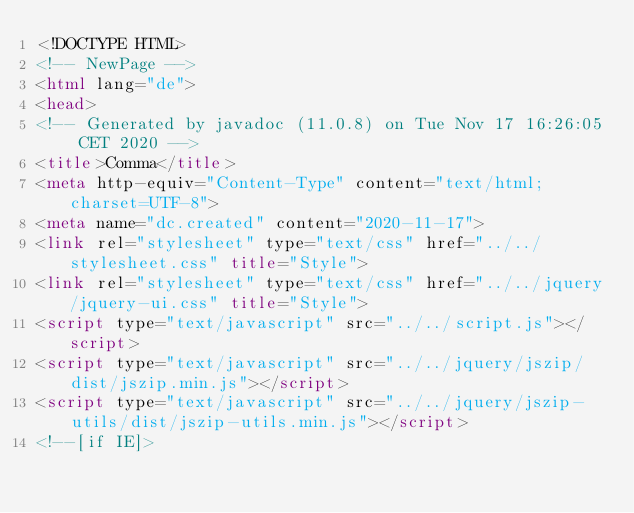<code> <loc_0><loc_0><loc_500><loc_500><_HTML_><!DOCTYPE HTML>
<!-- NewPage -->
<html lang="de">
<head>
<!-- Generated by javadoc (11.0.8) on Tue Nov 17 16:26:05 CET 2020 -->
<title>Comma</title>
<meta http-equiv="Content-Type" content="text/html; charset=UTF-8">
<meta name="dc.created" content="2020-11-17">
<link rel="stylesheet" type="text/css" href="../../stylesheet.css" title="Style">
<link rel="stylesheet" type="text/css" href="../../jquery/jquery-ui.css" title="Style">
<script type="text/javascript" src="../../script.js"></script>
<script type="text/javascript" src="../../jquery/jszip/dist/jszip.min.js"></script>
<script type="text/javascript" src="../../jquery/jszip-utils/dist/jszip-utils.min.js"></script>
<!--[if IE]></code> 